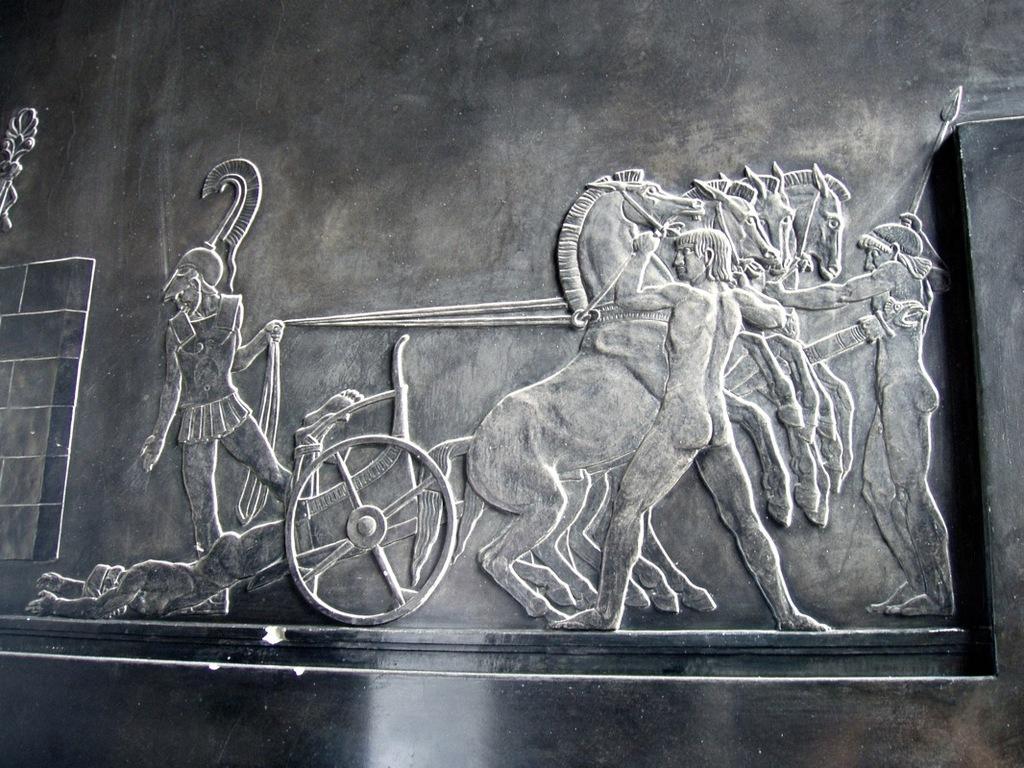How would you summarize this image in a sentence or two? In this image there is a carving of a person is riding the horse cart, on the right side 2 men are standing and opposing these horses. 